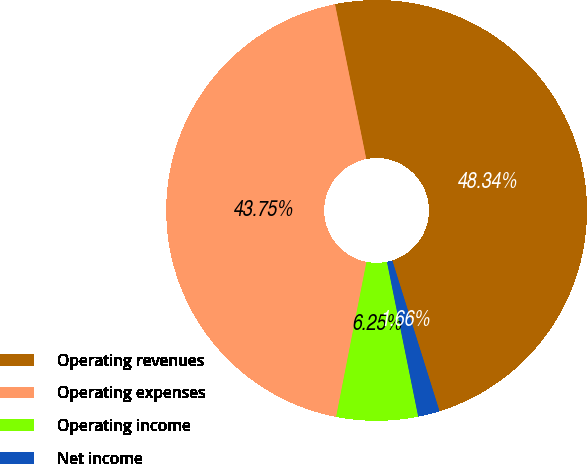Convert chart to OTSL. <chart><loc_0><loc_0><loc_500><loc_500><pie_chart><fcel>Operating revenues<fcel>Operating expenses<fcel>Operating income<fcel>Net income<nl><fcel>48.34%<fcel>43.75%<fcel>6.25%<fcel>1.66%<nl></chart> 